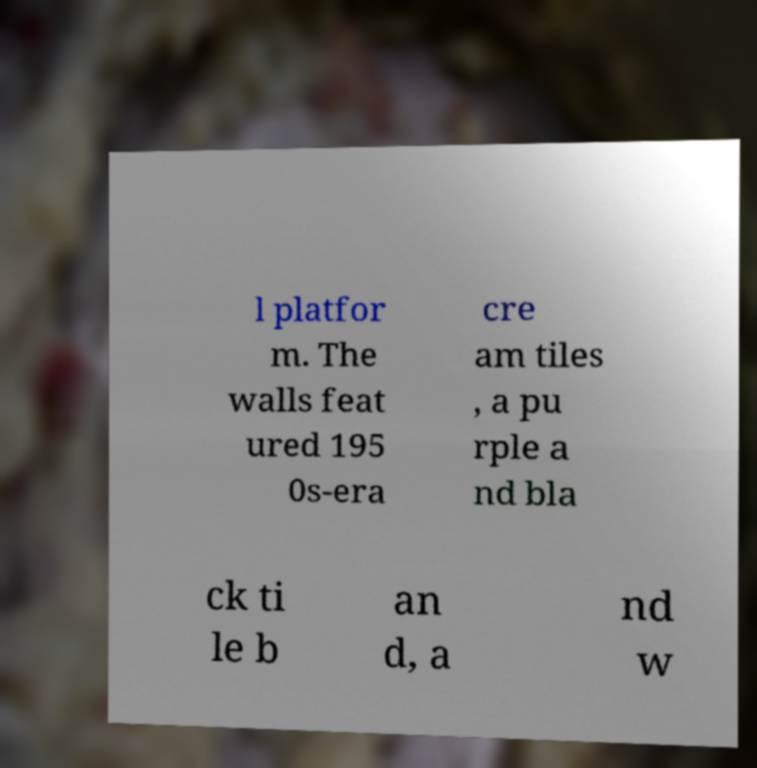Please read and relay the text visible in this image. What does it say? l platfor m. The walls feat ured 195 0s-era cre am tiles , a pu rple a nd bla ck ti le b an d, a nd w 